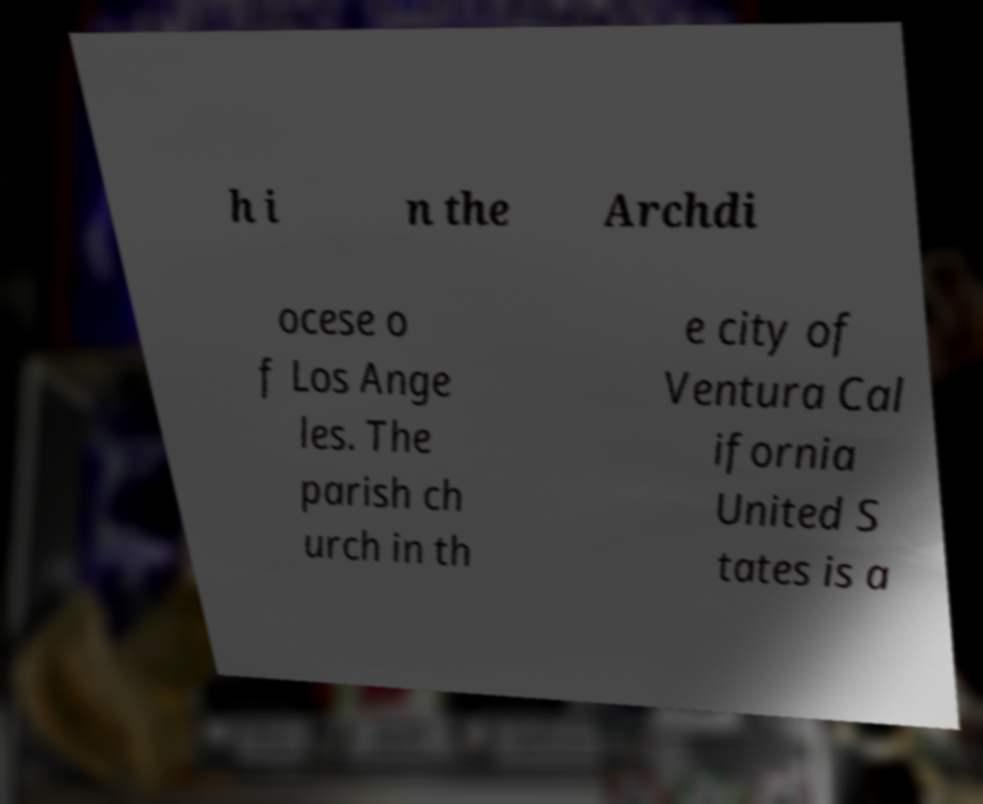Can you accurately transcribe the text from the provided image for me? h i n the Archdi ocese o f Los Ange les. The parish ch urch in th e city of Ventura Cal ifornia United S tates is a 